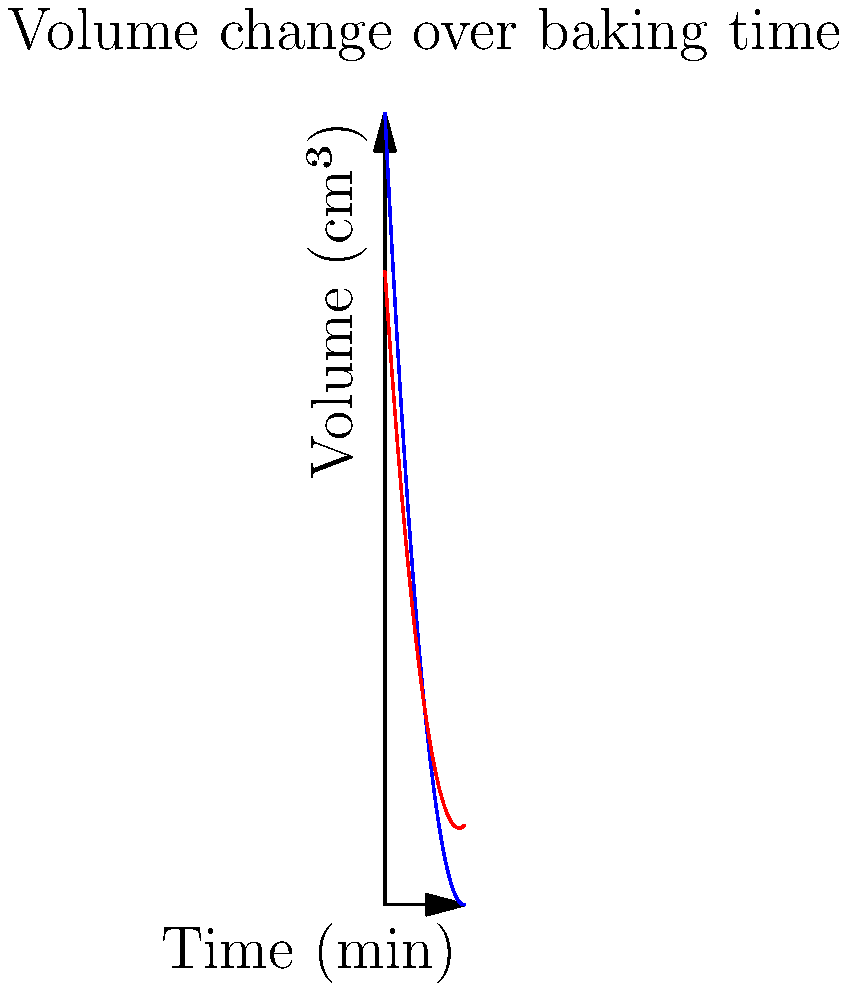The graph shows the volume change of a pastry during baking, comparing the original recipe (blue) and a fat-reduced version (red). If the pastry is baked for 5 minutes, estimate the percentage reduction in volume for the fat-reduced version compared to the original. To solve this problem, we need to follow these steps:

1. Determine the volume of the original pastry at 5 minutes:
   Original volume ≈ 75 cm³ (from the blue curve)

2. Determine the volume of the fat-reduced pastry at 5 minutes:
   Fat-reduced volume ≈ 65 cm³ (from the red curve)

3. Calculate the volume difference:
   Volume difference = 75 cm³ - 65 cm³ = 10 cm³

4. Calculate the percentage reduction:
   Percentage reduction = (Volume difference / Original volume) × 100
   = (10 cm³ / 75 cm³) × 100
   ≈ 13.33%

5. Round to the nearest whole number:
   13%

Therefore, the estimated percentage reduction in volume for the fat-reduced version compared to the original is approximately 13%.
Answer: 13% 